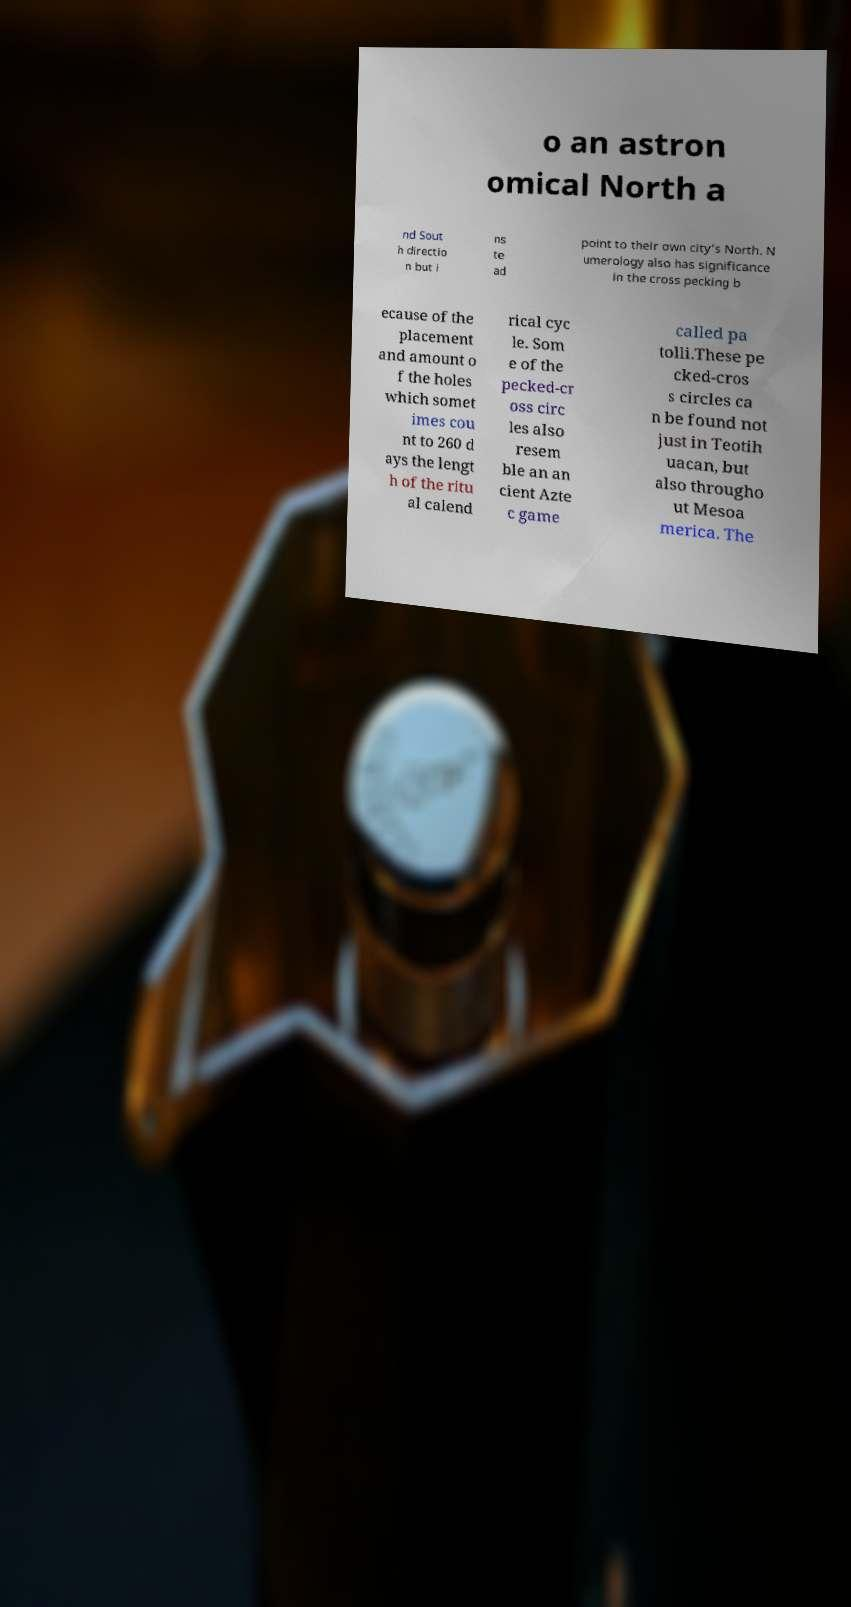For documentation purposes, I need the text within this image transcribed. Could you provide that? o an astron omical North a nd Sout h directio n but i ns te ad point to their own city’s North. N umerology also has significance in the cross pecking b ecause of the placement and amount o f the holes which somet imes cou nt to 260 d ays the lengt h of the ritu al calend rical cyc le. Som e of the pecked-cr oss circ les also resem ble an an cient Azte c game called pa tolli.These pe cked-cros s circles ca n be found not just in Teotih uacan, but also througho ut Mesoa merica. The 